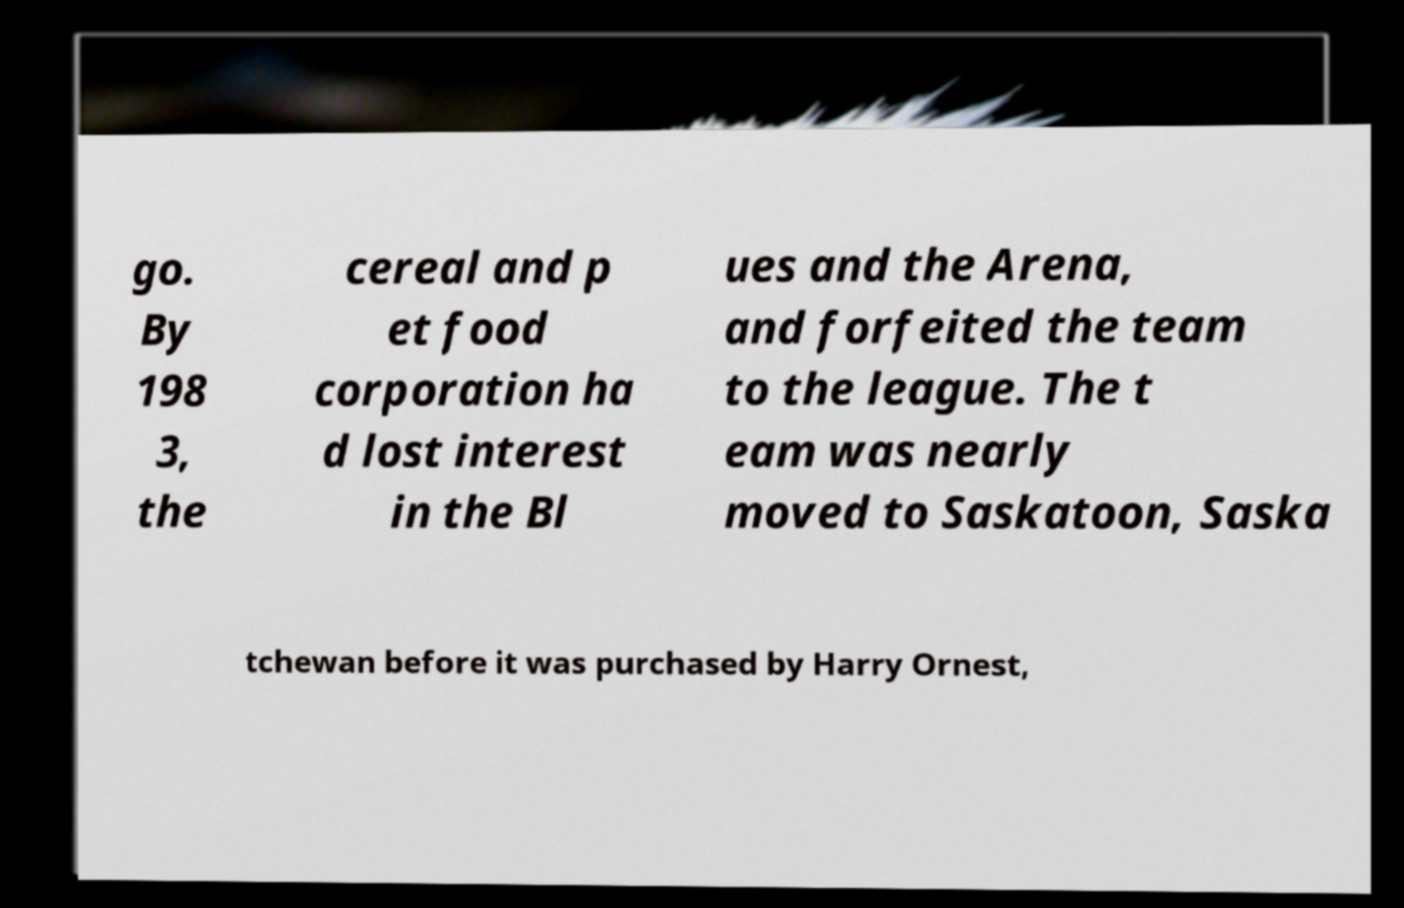What messages or text are displayed in this image? I need them in a readable, typed format. go. By 198 3, the cereal and p et food corporation ha d lost interest in the Bl ues and the Arena, and forfeited the team to the league. The t eam was nearly moved to Saskatoon, Saska tchewan before it was purchased by Harry Ornest, 